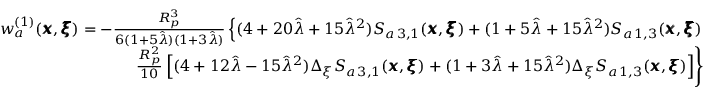<formula> <loc_0><loc_0><loc_500><loc_500>\begin{array} { r l r } & { w _ { a } ^ { ( 1 ) } ( { \pm b x } , { \pm b \xi } ) = - \frac { R _ { p } ^ { 3 } } { 6 ( 1 + 5 \hat { \lambda } ) ( 1 + 3 \hat { \lambda } ) } \left \{ ( 4 + 2 0 \hat { \lambda } + 1 5 \hat { \lambda } ^ { 2 } ) S _ { a \, 3 , 1 } ( { \pm b x } , { \pm b \xi } ) + ( 1 + 5 \hat { \lambda } + 1 5 \hat { \lambda } ^ { 2 } ) S _ { a \, 1 , 3 } ( { \pm b x } , { \pm b \xi } ) } \\ & { \frac { R _ { p } ^ { 2 } } { 1 0 } \left [ ( 4 + 1 2 \hat { \lambda } - 1 5 \hat { \lambda } ^ { 2 } ) \Delta _ { \xi } S _ { a \, 3 , 1 } ( { \pm b x } , { \pm b \xi } ) + ( 1 + 3 \hat { \lambda } + 1 5 \hat { \lambda } ^ { 2 } ) \Delta _ { \xi } S _ { a \, 1 , 3 } ( { \pm b x } , { \pm b \xi } ) \right ] \right \} } \end{array}</formula> 